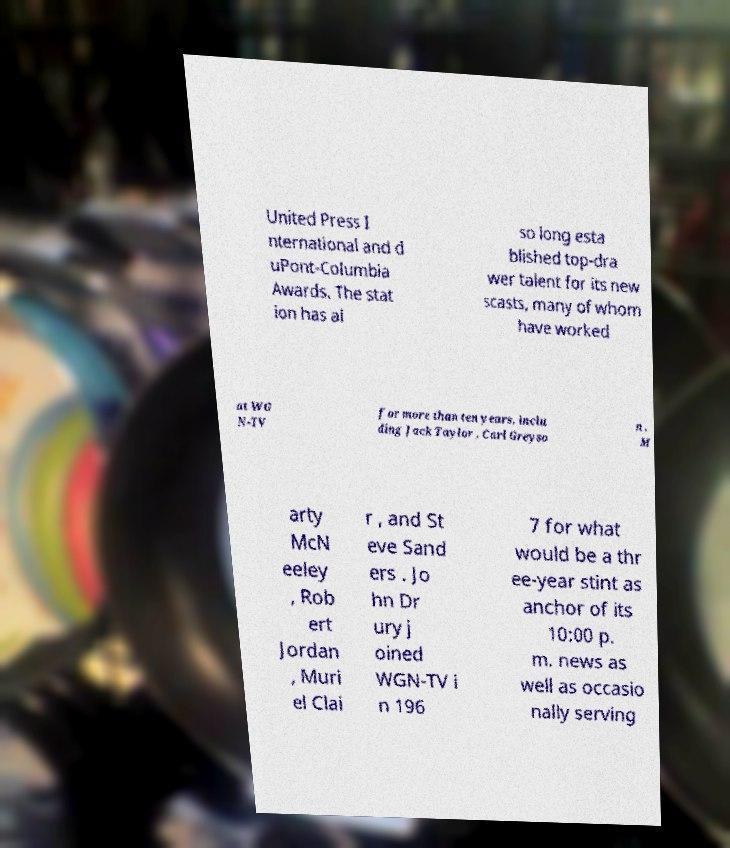I need the written content from this picture converted into text. Can you do that? United Press I nternational and d uPont-Columbia Awards. The stat ion has al so long esta blished top-dra wer talent for its new scasts, many of whom have worked at WG N-TV for more than ten years, inclu ding Jack Taylor , Carl Greyso n , M arty McN eeley , Rob ert Jordan , Muri el Clai r , and St eve Sand ers . Jo hn Dr ury j oined WGN-TV i n 196 7 for what would be a thr ee-year stint as anchor of its 10:00 p. m. news as well as occasio nally serving 